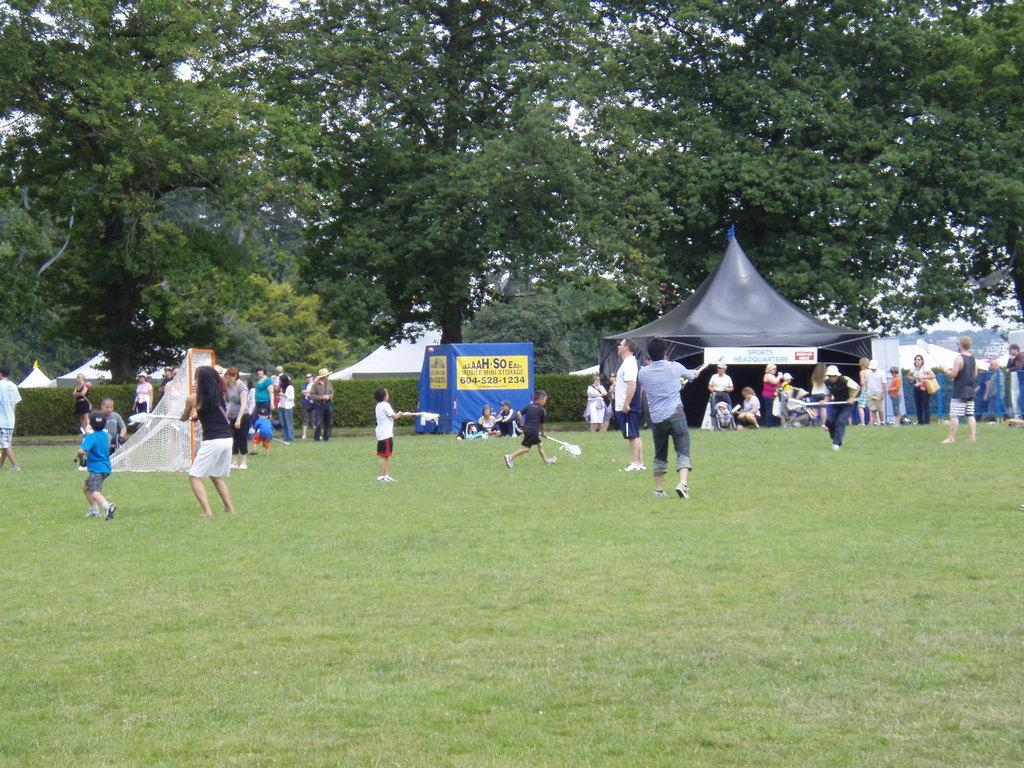Could you give a brief overview of what you see in this image? In this image we can see some people. And we can see some are sitting and some are standing. And we can see the grass. And we can see one tent. And we can see some objects in the people's hands. And we can see the trees. 